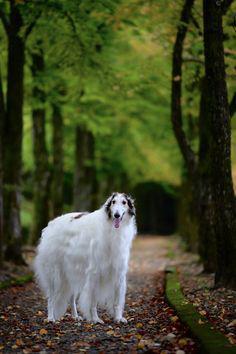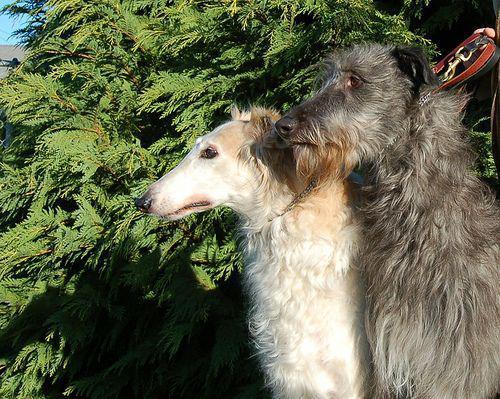The first image is the image on the left, the second image is the image on the right. For the images displayed, is the sentence "Each image shows exactly two furry hounds posed next to each other outdoors on grass." factually correct? Answer yes or no. No. The first image is the image on the left, the second image is the image on the right. Given the left and right images, does the statement "There are two dogs in each image." hold true? Answer yes or no. No. 